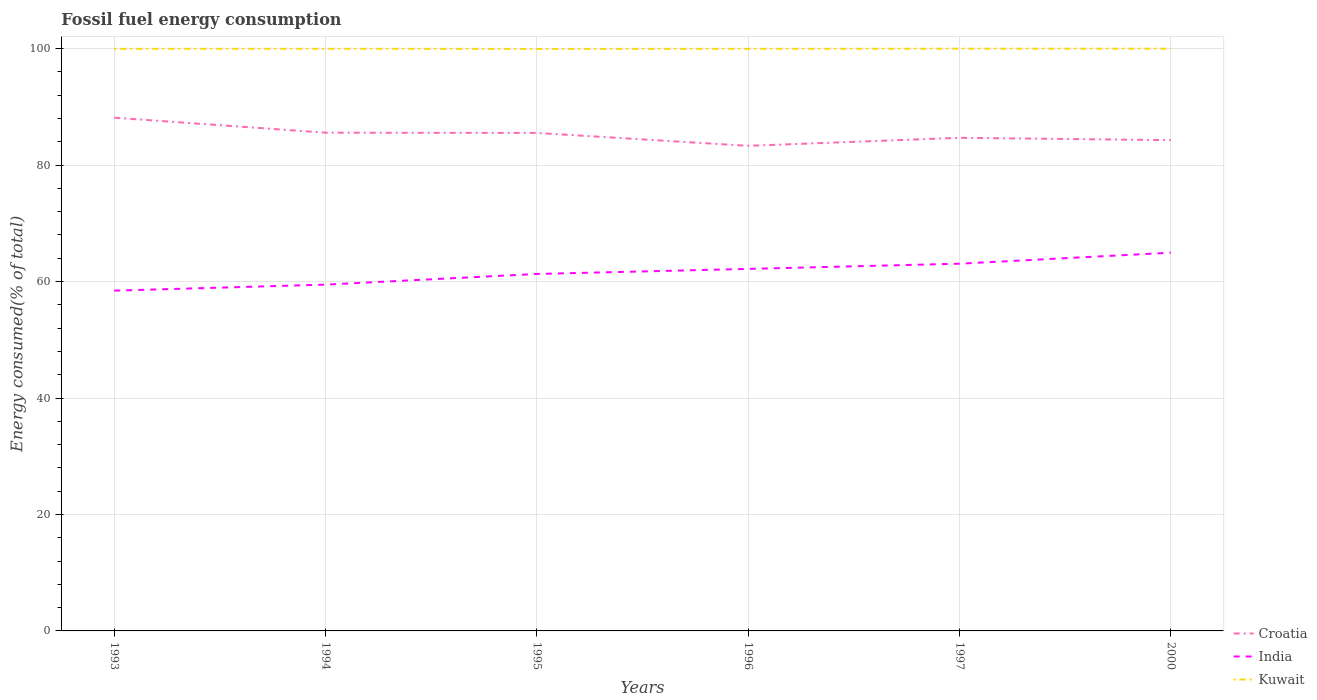Does the line corresponding to Croatia intersect with the line corresponding to Kuwait?
Provide a succinct answer. No. Is the number of lines equal to the number of legend labels?
Offer a very short reply. Yes. Across all years, what is the maximum percentage of energy consumed in India?
Ensure brevity in your answer.  58.44. What is the total percentage of energy consumed in Croatia in the graph?
Your answer should be very brief. 2.26. What is the difference between the highest and the second highest percentage of energy consumed in Kuwait?
Ensure brevity in your answer.  0.04. What is the difference between the highest and the lowest percentage of energy consumed in India?
Your answer should be very brief. 3. How many lines are there?
Ensure brevity in your answer.  3. What is the difference between two consecutive major ticks on the Y-axis?
Ensure brevity in your answer.  20. Does the graph contain any zero values?
Provide a succinct answer. No. What is the title of the graph?
Your answer should be compact. Fossil fuel energy consumption. Does "Uganda" appear as one of the legend labels in the graph?
Make the answer very short. No. What is the label or title of the Y-axis?
Provide a short and direct response. Energy consumed(% of total). What is the Energy consumed(% of total) in Croatia in 1993?
Give a very brief answer. 88.15. What is the Energy consumed(% of total) of India in 1993?
Your answer should be compact. 58.44. What is the Energy consumed(% of total) of Kuwait in 1993?
Your answer should be compact. 99.97. What is the Energy consumed(% of total) in Croatia in 1994?
Give a very brief answer. 85.57. What is the Energy consumed(% of total) in India in 1994?
Provide a short and direct response. 59.48. What is the Energy consumed(% of total) of Kuwait in 1994?
Your response must be concise. 99.98. What is the Energy consumed(% of total) of Croatia in 1995?
Provide a short and direct response. 85.53. What is the Energy consumed(% of total) of India in 1995?
Your answer should be very brief. 61.31. What is the Energy consumed(% of total) of Kuwait in 1995?
Ensure brevity in your answer.  99.96. What is the Energy consumed(% of total) in Croatia in 1996?
Offer a very short reply. 83.31. What is the Energy consumed(% of total) of India in 1996?
Your answer should be compact. 62.18. What is the Energy consumed(% of total) of Kuwait in 1996?
Your answer should be compact. 99.97. What is the Energy consumed(% of total) of Croatia in 1997?
Offer a terse response. 84.69. What is the Energy consumed(% of total) in India in 1997?
Your response must be concise. 63.07. What is the Energy consumed(% of total) of Kuwait in 1997?
Provide a short and direct response. 100. What is the Energy consumed(% of total) in Croatia in 2000?
Your answer should be compact. 84.29. What is the Energy consumed(% of total) in India in 2000?
Ensure brevity in your answer.  64.96. What is the Energy consumed(% of total) in Kuwait in 2000?
Offer a very short reply. 100. Across all years, what is the maximum Energy consumed(% of total) in Croatia?
Offer a terse response. 88.15. Across all years, what is the maximum Energy consumed(% of total) in India?
Provide a succinct answer. 64.96. Across all years, what is the maximum Energy consumed(% of total) of Kuwait?
Give a very brief answer. 100. Across all years, what is the minimum Energy consumed(% of total) of Croatia?
Ensure brevity in your answer.  83.31. Across all years, what is the minimum Energy consumed(% of total) of India?
Your answer should be compact. 58.44. Across all years, what is the minimum Energy consumed(% of total) of Kuwait?
Provide a short and direct response. 99.96. What is the total Energy consumed(% of total) of Croatia in the graph?
Provide a short and direct response. 511.54. What is the total Energy consumed(% of total) in India in the graph?
Ensure brevity in your answer.  369.43. What is the total Energy consumed(% of total) of Kuwait in the graph?
Make the answer very short. 599.89. What is the difference between the Energy consumed(% of total) in Croatia in 1993 and that in 1994?
Your response must be concise. 2.58. What is the difference between the Energy consumed(% of total) in India in 1993 and that in 1994?
Your answer should be very brief. -1.04. What is the difference between the Energy consumed(% of total) in Kuwait in 1993 and that in 1994?
Make the answer very short. -0.01. What is the difference between the Energy consumed(% of total) in Croatia in 1993 and that in 1995?
Give a very brief answer. 2.62. What is the difference between the Energy consumed(% of total) in India in 1993 and that in 1995?
Offer a terse response. -2.87. What is the difference between the Energy consumed(% of total) in Kuwait in 1993 and that in 1995?
Offer a terse response. 0.01. What is the difference between the Energy consumed(% of total) of Croatia in 1993 and that in 1996?
Provide a succinct answer. 4.84. What is the difference between the Energy consumed(% of total) in India in 1993 and that in 1996?
Give a very brief answer. -3.74. What is the difference between the Energy consumed(% of total) in Kuwait in 1993 and that in 1996?
Your response must be concise. -0. What is the difference between the Energy consumed(% of total) in Croatia in 1993 and that in 1997?
Ensure brevity in your answer.  3.46. What is the difference between the Energy consumed(% of total) in India in 1993 and that in 1997?
Offer a very short reply. -4.63. What is the difference between the Energy consumed(% of total) in Kuwait in 1993 and that in 1997?
Provide a short and direct response. -0.03. What is the difference between the Energy consumed(% of total) of Croatia in 1993 and that in 2000?
Make the answer very short. 3.86. What is the difference between the Energy consumed(% of total) in India in 1993 and that in 2000?
Keep it short and to the point. -6.52. What is the difference between the Energy consumed(% of total) of Kuwait in 1993 and that in 2000?
Keep it short and to the point. -0.03. What is the difference between the Energy consumed(% of total) of Croatia in 1994 and that in 1995?
Your response must be concise. 0.04. What is the difference between the Energy consumed(% of total) of India in 1994 and that in 1995?
Provide a short and direct response. -1.83. What is the difference between the Energy consumed(% of total) of Kuwait in 1994 and that in 1995?
Give a very brief answer. 0.03. What is the difference between the Energy consumed(% of total) in Croatia in 1994 and that in 1996?
Your answer should be compact. 2.26. What is the difference between the Energy consumed(% of total) of India in 1994 and that in 1996?
Provide a succinct answer. -2.7. What is the difference between the Energy consumed(% of total) of Kuwait in 1994 and that in 1996?
Offer a very short reply. 0.01. What is the difference between the Energy consumed(% of total) of Croatia in 1994 and that in 1997?
Offer a very short reply. 0.88. What is the difference between the Energy consumed(% of total) of India in 1994 and that in 1997?
Provide a short and direct response. -3.59. What is the difference between the Energy consumed(% of total) in Kuwait in 1994 and that in 1997?
Keep it short and to the point. -0.02. What is the difference between the Energy consumed(% of total) in Croatia in 1994 and that in 2000?
Your answer should be very brief. 1.28. What is the difference between the Energy consumed(% of total) of India in 1994 and that in 2000?
Offer a very short reply. -5.49. What is the difference between the Energy consumed(% of total) of Kuwait in 1994 and that in 2000?
Give a very brief answer. -0.02. What is the difference between the Energy consumed(% of total) of Croatia in 1995 and that in 1996?
Provide a succinct answer. 2.22. What is the difference between the Energy consumed(% of total) in India in 1995 and that in 1996?
Offer a terse response. -0.87. What is the difference between the Energy consumed(% of total) in Kuwait in 1995 and that in 1996?
Keep it short and to the point. -0.02. What is the difference between the Energy consumed(% of total) in Croatia in 1995 and that in 1997?
Give a very brief answer. 0.84. What is the difference between the Energy consumed(% of total) in India in 1995 and that in 1997?
Your response must be concise. -1.76. What is the difference between the Energy consumed(% of total) of Kuwait in 1995 and that in 1997?
Your answer should be very brief. -0.04. What is the difference between the Energy consumed(% of total) in Croatia in 1995 and that in 2000?
Keep it short and to the point. 1.24. What is the difference between the Energy consumed(% of total) in India in 1995 and that in 2000?
Offer a very short reply. -3.65. What is the difference between the Energy consumed(% of total) of Kuwait in 1995 and that in 2000?
Give a very brief answer. -0.04. What is the difference between the Energy consumed(% of total) of Croatia in 1996 and that in 1997?
Make the answer very short. -1.38. What is the difference between the Energy consumed(% of total) in India in 1996 and that in 1997?
Keep it short and to the point. -0.89. What is the difference between the Energy consumed(% of total) in Kuwait in 1996 and that in 1997?
Your response must be concise. -0.03. What is the difference between the Energy consumed(% of total) of Croatia in 1996 and that in 2000?
Give a very brief answer. -0.98. What is the difference between the Energy consumed(% of total) of India in 1996 and that in 2000?
Keep it short and to the point. -2.79. What is the difference between the Energy consumed(% of total) in Kuwait in 1996 and that in 2000?
Give a very brief answer. -0.03. What is the difference between the Energy consumed(% of total) of Croatia in 1997 and that in 2000?
Ensure brevity in your answer.  0.4. What is the difference between the Energy consumed(% of total) in India in 1997 and that in 2000?
Give a very brief answer. -1.89. What is the difference between the Energy consumed(% of total) in Croatia in 1993 and the Energy consumed(% of total) in India in 1994?
Offer a terse response. 28.67. What is the difference between the Energy consumed(% of total) in Croatia in 1993 and the Energy consumed(% of total) in Kuwait in 1994?
Offer a terse response. -11.84. What is the difference between the Energy consumed(% of total) of India in 1993 and the Energy consumed(% of total) of Kuwait in 1994?
Your answer should be very brief. -41.55. What is the difference between the Energy consumed(% of total) of Croatia in 1993 and the Energy consumed(% of total) of India in 1995?
Your answer should be compact. 26.84. What is the difference between the Energy consumed(% of total) in Croatia in 1993 and the Energy consumed(% of total) in Kuwait in 1995?
Keep it short and to the point. -11.81. What is the difference between the Energy consumed(% of total) of India in 1993 and the Energy consumed(% of total) of Kuwait in 1995?
Keep it short and to the point. -41.52. What is the difference between the Energy consumed(% of total) of Croatia in 1993 and the Energy consumed(% of total) of India in 1996?
Your answer should be very brief. 25.97. What is the difference between the Energy consumed(% of total) in Croatia in 1993 and the Energy consumed(% of total) in Kuwait in 1996?
Offer a terse response. -11.83. What is the difference between the Energy consumed(% of total) in India in 1993 and the Energy consumed(% of total) in Kuwait in 1996?
Your response must be concise. -41.54. What is the difference between the Energy consumed(% of total) of Croatia in 1993 and the Energy consumed(% of total) of India in 1997?
Your answer should be very brief. 25.08. What is the difference between the Energy consumed(% of total) of Croatia in 1993 and the Energy consumed(% of total) of Kuwait in 1997?
Provide a short and direct response. -11.85. What is the difference between the Energy consumed(% of total) in India in 1993 and the Energy consumed(% of total) in Kuwait in 1997?
Ensure brevity in your answer.  -41.56. What is the difference between the Energy consumed(% of total) in Croatia in 1993 and the Energy consumed(% of total) in India in 2000?
Provide a short and direct response. 23.19. What is the difference between the Energy consumed(% of total) of Croatia in 1993 and the Energy consumed(% of total) of Kuwait in 2000?
Give a very brief answer. -11.85. What is the difference between the Energy consumed(% of total) in India in 1993 and the Energy consumed(% of total) in Kuwait in 2000?
Offer a very short reply. -41.56. What is the difference between the Energy consumed(% of total) in Croatia in 1994 and the Energy consumed(% of total) in India in 1995?
Offer a very short reply. 24.26. What is the difference between the Energy consumed(% of total) in Croatia in 1994 and the Energy consumed(% of total) in Kuwait in 1995?
Offer a terse response. -14.39. What is the difference between the Energy consumed(% of total) in India in 1994 and the Energy consumed(% of total) in Kuwait in 1995?
Ensure brevity in your answer.  -40.48. What is the difference between the Energy consumed(% of total) of Croatia in 1994 and the Energy consumed(% of total) of India in 1996?
Make the answer very short. 23.39. What is the difference between the Energy consumed(% of total) in Croatia in 1994 and the Energy consumed(% of total) in Kuwait in 1996?
Make the answer very short. -14.41. What is the difference between the Energy consumed(% of total) of India in 1994 and the Energy consumed(% of total) of Kuwait in 1996?
Provide a short and direct response. -40.5. What is the difference between the Energy consumed(% of total) of Croatia in 1994 and the Energy consumed(% of total) of India in 1997?
Your answer should be very brief. 22.5. What is the difference between the Energy consumed(% of total) of Croatia in 1994 and the Energy consumed(% of total) of Kuwait in 1997?
Make the answer very short. -14.43. What is the difference between the Energy consumed(% of total) of India in 1994 and the Energy consumed(% of total) of Kuwait in 1997?
Provide a succinct answer. -40.52. What is the difference between the Energy consumed(% of total) in Croatia in 1994 and the Energy consumed(% of total) in India in 2000?
Keep it short and to the point. 20.61. What is the difference between the Energy consumed(% of total) of Croatia in 1994 and the Energy consumed(% of total) of Kuwait in 2000?
Provide a succinct answer. -14.43. What is the difference between the Energy consumed(% of total) in India in 1994 and the Energy consumed(% of total) in Kuwait in 2000?
Ensure brevity in your answer.  -40.52. What is the difference between the Energy consumed(% of total) of Croatia in 1995 and the Energy consumed(% of total) of India in 1996?
Keep it short and to the point. 23.35. What is the difference between the Energy consumed(% of total) in Croatia in 1995 and the Energy consumed(% of total) in Kuwait in 1996?
Ensure brevity in your answer.  -14.44. What is the difference between the Energy consumed(% of total) of India in 1995 and the Energy consumed(% of total) of Kuwait in 1996?
Offer a very short reply. -38.67. What is the difference between the Energy consumed(% of total) in Croatia in 1995 and the Energy consumed(% of total) in India in 1997?
Your answer should be very brief. 22.46. What is the difference between the Energy consumed(% of total) in Croatia in 1995 and the Energy consumed(% of total) in Kuwait in 1997?
Offer a very short reply. -14.47. What is the difference between the Energy consumed(% of total) in India in 1995 and the Energy consumed(% of total) in Kuwait in 1997?
Provide a short and direct response. -38.69. What is the difference between the Energy consumed(% of total) in Croatia in 1995 and the Energy consumed(% of total) in India in 2000?
Offer a very short reply. 20.57. What is the difference between the Energy consumed(% of total) in Croatia in 1995 and the Energy consumed(% of total) in Kuwait in 2000?
Your answer should be compact. -14.47. What is the difference between the Energy consumed(% of total) of India in 1995 and the Energy consumed(% of total) of Kuwait in 2000?
Offer a terse response. -38.69. What is the difference between the Energy consumed(% of total) of Croatia in 1996 and the Energy consumed(% of total) of India in 1997?
Your answer should be compact. 20.24. What is the difference between the Energy consumed(% of total) in Croatia in 1996 and the Energy consumed(% of total) in Kuwait in 1997?
Your answer should be very brief. -16.69. What is the difference between the Energy consumed(% of total) of India in 1996 and the Energy consumed(% of total) of Kuwait in 1997?
Your response must be concise. -37.82. What is the difference between the Energy consumed(% of total) in Croatia in 1996 and the Energy consumed(% of total) in India in 2000?
Ensure brevity in your answer.  18.35. What is the difference between the Energy consumed(% of total) of Croatia in 1996 and the Energy consumed(% of total) of Kuwait in 2000?
Make the answer very short. -16.69. What is the difference between the Energy consumed(% of total) of India in 1996 and the Energy consumed(% of total) of Kuwait in 2000?
Keep it short and to the point. -37.82. What is the difference between the Energy consumed(% of total) in Croatia in 1997 and the Energy consumed(% of total) in India in 2000?
Provide a succinct answer. 19.73. What is the difference between the Energy consumed(% of total) in Croatia in 1997 and the Energy consumed(% of total) in Kuwait in 2000?
Keep it short and to the point. -15.31. What is the difference between the Energy consumed(% of total) in India in 1997 and the Energy consumed(% of total) in Kuwait in 2000?
Make the answer very short. -36.93. What is the average Energy consumed(% of total) in Croatia per year?
Provide a short and direct response. 85.26. What is the average Energy consumed(% of total) in India per year?
Give a very brief answer. 61.57. What is the average Energy consumed(% of total) in Kuwait per year?
Give a very brief answer. 99.98. In the year 1993, what is the difference between the Energy consumed(% of total) in Croatia and Energy consumed(% of total) in India?
Provide a short and direct response. 29.71. In the year 1993, what is the difference between the Energy consumed(% of total) in Croatia and Energy consumed(% of total) in Kuwait?
Provide a succinct answer. -11.82. In the year 1993, what is the difference between the Energy consumed(% of total) in India and Energy consumed(% of total) in Kuwait?
Provide a succinct answer. -41.53. In the year 1994, what is the difference between the Energy consumed(% of total) of Croatia and Energy consumed(% of total) of India?
Make the answer very short. 26.09. In the year 1994, what is the difference between the Energy consumed(% of total) of Croatia and Energy consumed(% of total) of Kuwait?
Give a very brief answer. -14.42. In the year 1994, what is the difference between the Energy consumed(% of total) in India and Energy consumed(% of total) in Kuwait?
Give a very brief answer. -40.51. In the year 1995, what is the difference between the Energy consumed(% of total) of Croatia and Energy consumed(% of total) of India?
Provide a short and direct response. 24.22. In the year 1995, what is the difference between the Energy consumed(% of total) in Croatia and Energy consumed(% of total) in Kuwait?
Provide a short and direct response. -14.43. In the year 1995, what is the difference between the Energy consumed(% of total) of India and Energy consumed(% of total) of Kuwait?
Your response must be concise. -38.65. In the year 1996, what is the difference between the Energy consumed(% of total) of Croatia and Energy consumed(% of total) of India?
Your answer should be very brief. 21.14. In the year 1996, what is the difference between the Energy consumed(% of total) of Croatia and Energy consumed(% of total) of Kuwait?
Give a very brief answer. -16.66. In the year 1996, what is the difference between the Energy consumed(% of total) of India and Energy consumed(% of total) of Kuwait?
Offer a terse response. -37.8. In the year 1997, what is the difference between the Energy consumed(% of total) of Croatia and Energy consumed(% of total) of India?
Provide a short and direct response. 21.62. In the year 1997, what is the difference between the Energy consumed(% of total) of Croatia and Energy consumed(% of total) of Kuwait?
Your response must be concise. -15.31. In the year 1997, what is the difference between the Energy consumed(% of total) in India and Energy consumed(% of total) in Kuwait?
Ensure brevity in your answer.  -36.93. In the year 2000, what is the difference between the Energy consumed(% of total) of Croatia and Energy consumed(% of total) of India?
Your answer should be compact. 19.33. In the year 2000, what is the difference between the Energy consumed(% of total) in Croatia and Energy consumed(% of total) in Kuwait?
Provide a short and direct response. -15.71. In the year 2000, what is the difference between the Energy consumed(% of total) of India and Energy consumed(% of total) of Kuwait?
Your response must be concise. -35.04. What is the ratio of the Energy consumed(% of total) of Croatia in 1993 to that in 1994?
Offer a very short reply. 1.03. What is the ratio of the Energy consumed(% of total) in India in 1993 to that in 1994?
Your answer should be compact. 0.98. What is the ratio of the Energy consumed(% of total) of Croatia in 1993 to that in 1995?
Provide a succinct answer. 1.03. What is the ratio of the Energy consumed(% of total) in India in 1993 to that in 1995?
Provide a short and direct response. 0.95. What is the ratio of the Energy consumed(% of total) in Kuwait in 1993 to that in 1995?
Give a very brief answer. 1. What is the ratio of the Energy consumed(% of total) of Croatia in 1993 to that in 1996?
Your answer should be very brief. 1.06. What is the ratio of the Energy consumed(% of total) in India in 1993 to that in 1996?
Provide a succinct answer. 0.94. What is the ratio of the Energy consumed(% of total) of Kuwait in 1993 to that in 1996?
Make the answer very short. 1. What is the ratio of the Energy consumed(% of total) of Croatia in 1993 to that in 1997?
Your response must be concise. 1.04. What is the ratio of the Energy consumed(% of total) of India in 1993 to that in 1997?
Your response must be concise. 0.93. What is the ratio of the Energy consumed(% of total) in Croatia in 1993 to that in 2000?
Your response must be concise. 1.05. What is the ratio of the Energy consumed(% of total) of India in 1993 to that in 2000?
Your answer should be compact. 0.9. What is the ratio of the Energy consumed(% of total) in India in 1994 to that in 1995?
Make the answer very short. 0.97. What is the ratio of the Energy consumed(% of total) of Croatia in 1994 to that in 1996?
Your answer should be very brief. 1.03. What is the ratio of the Energy consumed(% of total) in India in 1994 to that in 1996?
Offer a terse response. 0.96. What is the ratio of the Energy consumed(% of total) in Kuwait in 1994 to that in 1996?
Your answer should be very brief. 1. What is the ratio of the Energy consumed(% of total) in Croatia in 1994 to that in 1997?
Ensure brevity in your answer.  1.01. What is the ratio of the Energy consumed(% of total) in India in 1994 to that in 1997?
Provide a short and direct response. 0.94. What is the ratio of the Energy consumed(% of total) in Kuwait in 1994 to that in 1997?
Give a very brief answer. 1. What is the ratio of the Energy consumed(% of total) of Croatia in 1994 to that in 2000?
Your answer should be very brief. 1.02. What is the ratio of the Energy consumed(% of total) in India in 1994 to that in 2000?
Ensure brevity in your answer.  0.92. What is the ratio of the Energy consumed(% of total) of Kuwait in 1994 to that in 2000?
Give a very brief answer. 1. What is the ratio of the Energy consumed(% of total) in Croatia in 1995 to that in 1996?
Your answer should be compact. 1.03. What is the ratio of the Energy consumed(% of total) in India in 1995 to that in 1996?
Make the answer very short. 0.99. What is the ratio of the Energy consumed(% of total) of Croatia in 1995 to that in 1997?
Give a very brief answer. 1.01. What is the ratio of the Energy consumed(% of total) of India in 1995 to that in 1997?
Your response must be concise. 0.97. What is the ratio of the Energy consumed(% of total) in Croatia in 1995 to that in 2000?
Offer a terse response. 1.01. What is the ratio of the Energy consumed(% of total) in India in 1995 to that in 2000?
Your answer should be compact. 0.94. What is the ratio of the Energy consumed(% of total) of Croatia in 1996 to that in 1997?
Your answer should be compact. 0.98. What is the ratio of the Energy consumed(% of total) of India in 1996 to that in 1997?
Provide a succinct answer. 0.99. What is the ratio of the Energy consumed(% of total) in Kuwait in 1996 to that in 1997?
Keep it short and to the point. 1. What is the ratio of the Energy consumed(% of total) in Croatia in 1996 to that in 2000?
Offer a very short reply. 0.99. What is the ratio of the Energy consumed(% of total) of India in 1996 to that in 2000?
Your response must be concise. 0.96. What is the ratio of the Energy consumed(% of total) in India in 1997 to that in 2000?
Give a very brief answer. 0.97. What is the difference between the highest and the second highest Energy consumed(% of total) of Croatia?
Offer a very short reply. 2.58. What is the difference between the highest and the second highest Energy consumed(% of total) in India?
Offer a terse response. 1.89. What is the difference between the highest and the second highest Energy consumed(% of total) in Kuwait?
Your answer should be compact. 0. What is the difference between the highest and the lowest Energy consumed(% of total) in Croatia?
Provide a succinct answer. 4.84. What is the difference between the highest and the lowest Energy consumed(% of total) of India?
Your answer should be compact. 6.52. What is the difference between the highest and the lowest Energy consumed(% of total) of Kuwait?
Provide a succinct answer. 0.04. 